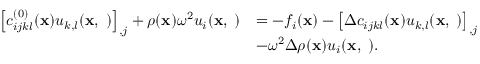<formula> <loc_0><loc_0><loc_500><loc_500>\begin{array} { r l } { \left [ c _ { i j k l } ^ { ( 0 ) } ( { x } ) u _ { k , l } ( { x , \omega } ) \right ] _ { , j } + \rho ( { x } ) \omega ^ { 2 } u _ { i } ( { x , \omega } ) } & { = - f _ { i } ( { x } ) - \left [ \Delta c _ { i j k l } ( { x } ) u _ { k , l } ( { x , \omega } ) \right ] _ { , j } } \\ & { - \omega ^ { 2 } \Delta \rho ( { x } ) u _ { i } ( { x , \omega } ) . } \end{array}</formula> 